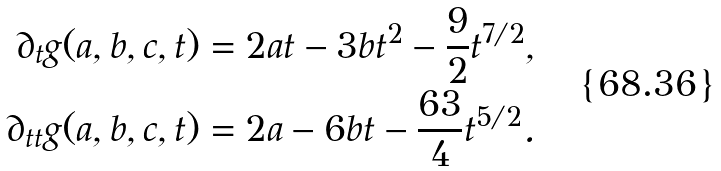<formula> <loc_0><loc_0><loc_500><loc_500>\partial _ { t } g ( a , b , c , t ) & = 2 a t - 3 b t ^ { 2 } - \frac { 9 } { 2 } t ^ { 7 / 2 } , \\ \partial _ { t t } g ( a , b , c , t ) & = 2 a - 6 b t - \frac { 6 3 } { 4 } t ^ { 5 / 2 } .</formula> 